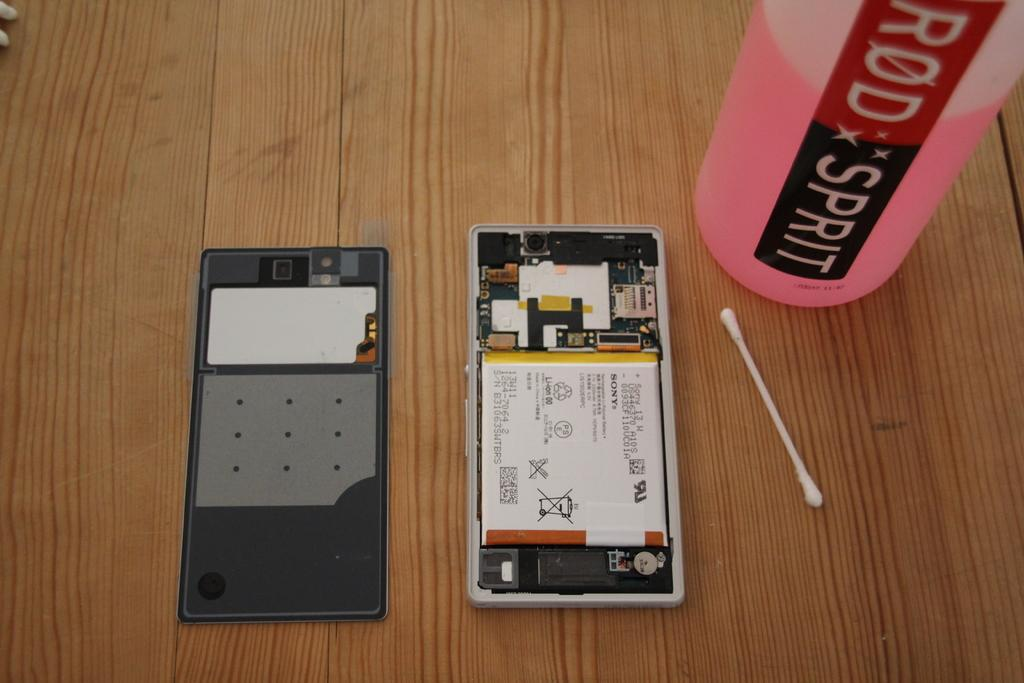<image>
Render a clear and concise summary of the photo. A cotton swab sits next to a bottle of Rod Sprit that contains pink liquid. 